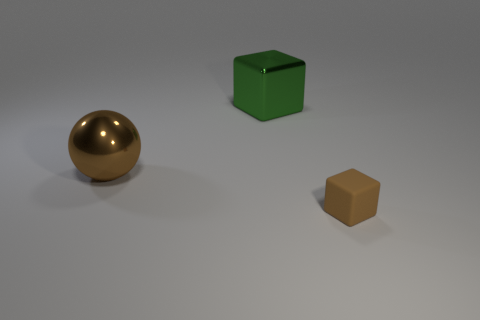The object that is on the right side of the sphere and in front of the big green metallic cube has what shape?
Provide a short and direct response. Cube. Is the number of shiny objects greater than the number of cylinders?
Provide a succinct answer. Yes. What is the material of the tiny brown block?
Provide a short and direct response. Rubber. Is there any other thing that is the same size as the green thing?
Give a very brief answer. Yes. The brown object that is the same shape as the green thing is what size?
Offer a terse response. Small. Is there a green metallic thing that is to the left of the big object in front of the large green metallic block?
Your answer should be compact. No. Do the metal sphere and the tiny object have the same color?
Offer a terse response. Yes. What number of other things are the same shape as the small brown matte object?
Provide a succinct answer. 1. Are there more green shiny objects that are behind the big block than large green metallic blocks to the right of the small thing?
Offer a terse response. No. Does the object in front of the large brown thing have the same size as the cube behind the tiny rubber object?
Provide a short and direct response. No. 